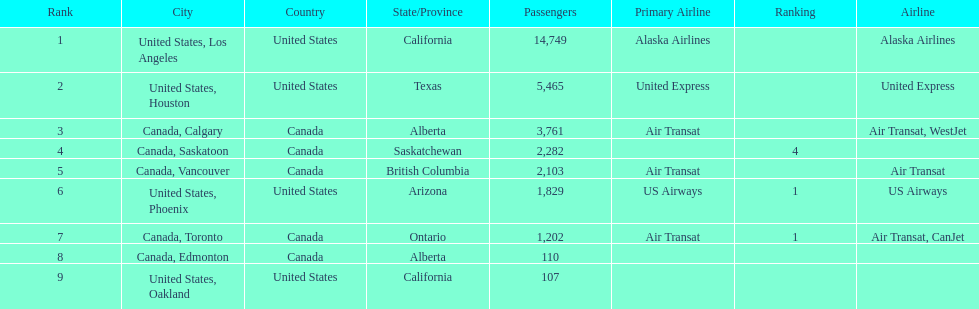How many airlines have a steady ranking? 4. 